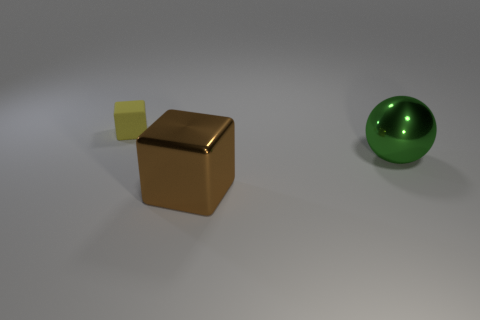Considering their sizes, how could these objects be used in a real-world setting? In a real-world setting, the brown cube could serve as a paperweight or a decorative object due to its metallic appearance and noticeable size. The smaller yellow cube might be part of a building block set for children to play with, while the green sphere could be a decorative orb placed in a bowl or used in a game as a ball. 